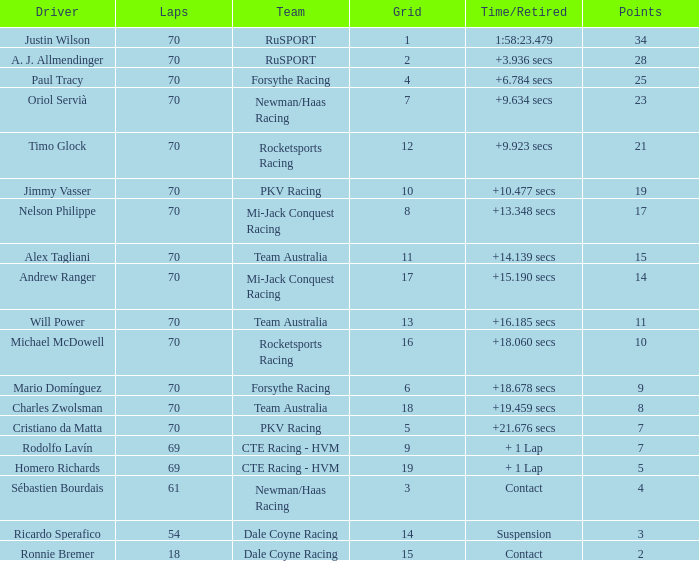Who scored with a grid of 10 and the highest amount of laps? 70.0. Can you parse all the data within this table? {'header': ['Driver', 'Laps', 'Team', 'Grid', 'Time/Retired', 'Points'], 'rows': [['Justin Wilson', '70', 'RuSPORT', '1', '1:58:23.479', '34'], ['A. J. Allmendinger', '70', 'RuSPORT', '2', '+3.936 secs', '28'], ['Paul Tracy', '70', 'Forsythe Racing', '4', '+6.784 secs', '25'], ['Oriol Servià', '70', 'Newman/Haas Racing', '7', '+9.634 secs', '23'], ['Timo Glock', '70', 'Rocketsports Racing', '12', '+9.923 secs', '21'], ['Jimmy Vasser', '70', 'PKV Racing', '10', '+10.477 secs', '19'], ['Nelson Philippe', '70', 'Mi-Jack Conquest Racing', '8', '+13.348 secs', '17'], ['Alex Tagliani', '70', 'Team Australia', '11', '+14.139 secs', '15'], ['Andrew Ranger', '70', 'Mi-Jack Conquest Racing', '17', '+15.190 secs', '14'], ['Will Power', '70', 'Team Australia', '13', '+16.185 secs', '11'], ['Michael McDowell', '70', 'Rocketsports Racing', '16', '+18.060 secs', '10'], ['Mario Domínguez', '70', 'Forsythe Racing', '6', '+18.678 secs', '9'], ['Charles Zwolsman', '70', 'Team Australia', '18', '+19.459 secs', '8'], ['Cristiano da Matta', '70', 'PKV Racing', '5', '+21.676 secs', '7'], ['Rodolfo Lavín', '69', 'CTE Racing - HVM', '9', '+ 1 Lap', '7'], ['Homero Richards', '69', 'CTE Racing - HVM', '19', '+ 1 Lap', '5'], ['Sébastien Bourdais', '61', 'Newman/Haas Racing', '3', 'Contact', '4'], ['Ricardo Sperafico', '54', 'Dale Coyne Racing', '14', 'Suspension', '3'], ['Ronnie Bremer', '18', 'Dale Coyne Racing', '15', 'Contact', '2']]} 